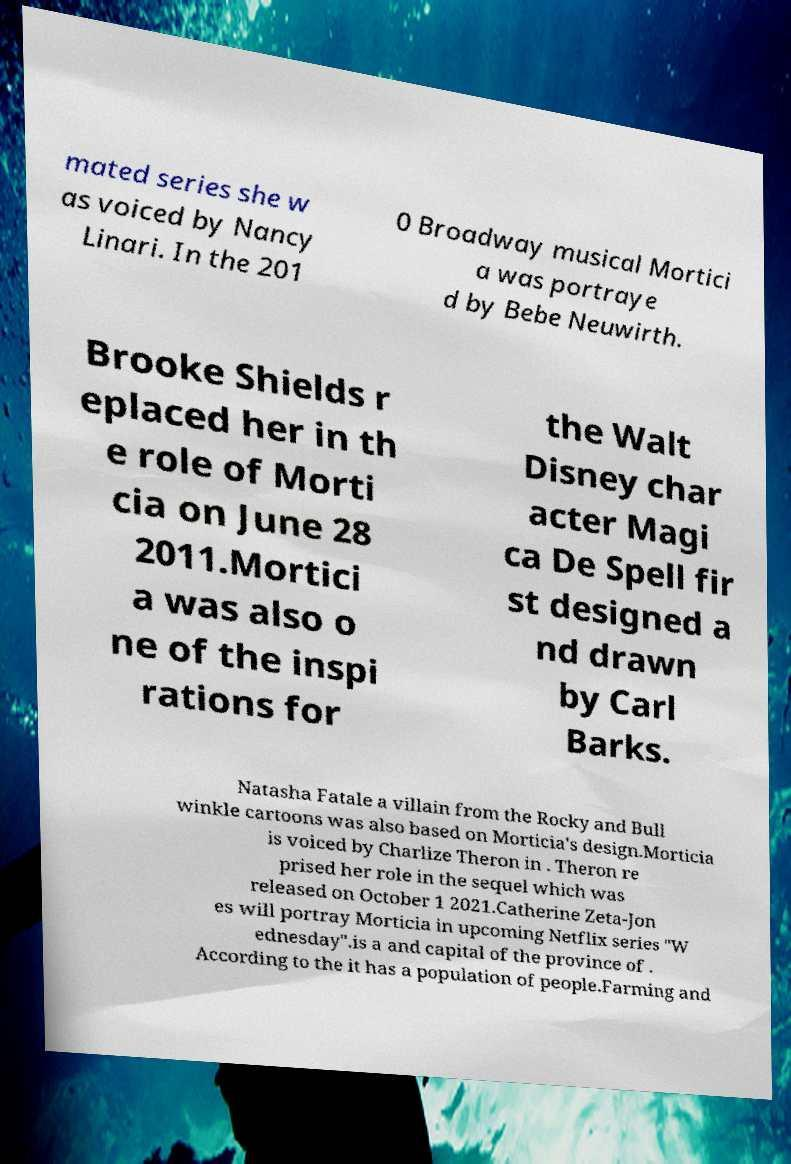There's text embedded in this image that I need extracted. Can you transcribe it verbatim? mated series she w as voiced by Nancy Linari. In the 201 0 Broadway musical Mortici a was portraye d by Bebe Neuwirth. Brooke Shields r eplaced her in th e role of Morti cia on June 28 2011.Mortici a was also o ne of the inspi rations for the Walt Disney char acter Magi ca De Spell fir st designed a nd drawn by Carl Barks. Natasha Fatale a villain from the Rocky and Bull winkle cartoons was also based on Morticia's design.Morticia is voiced by Charlize Theron in . Theron re prised her role in the sequel which was released on October 1 2021.Catherine Zeta-Jon es will portray Morticia in upcoming Netflix series "W ednesday".is a and capital of the province of . According to the it has a population of people.Farming and 